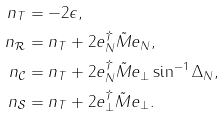<formula> <loc_0><loc_0><loc_500><loc_500>n _ { T } & = - 2 \epsilon , \\ n _ { \mathcal { R } } & = n _ { T } + 2 e _ { N } ^ { \dag } \tilde { M } e _ { N } , \\ n _ { \mathcal { C } } & = n _ { T } + 2 e _ { N } ^ { \dag } \tilde { M } e _ { \perp } \sin ^ { - 1 } \Delta _ { N } , \\ n _ { \mathcal { S } } & = n _ { T } + 2 e _ { \perp } ^ { \dag } \tilde { M } e _ { \perp } .</formula> 